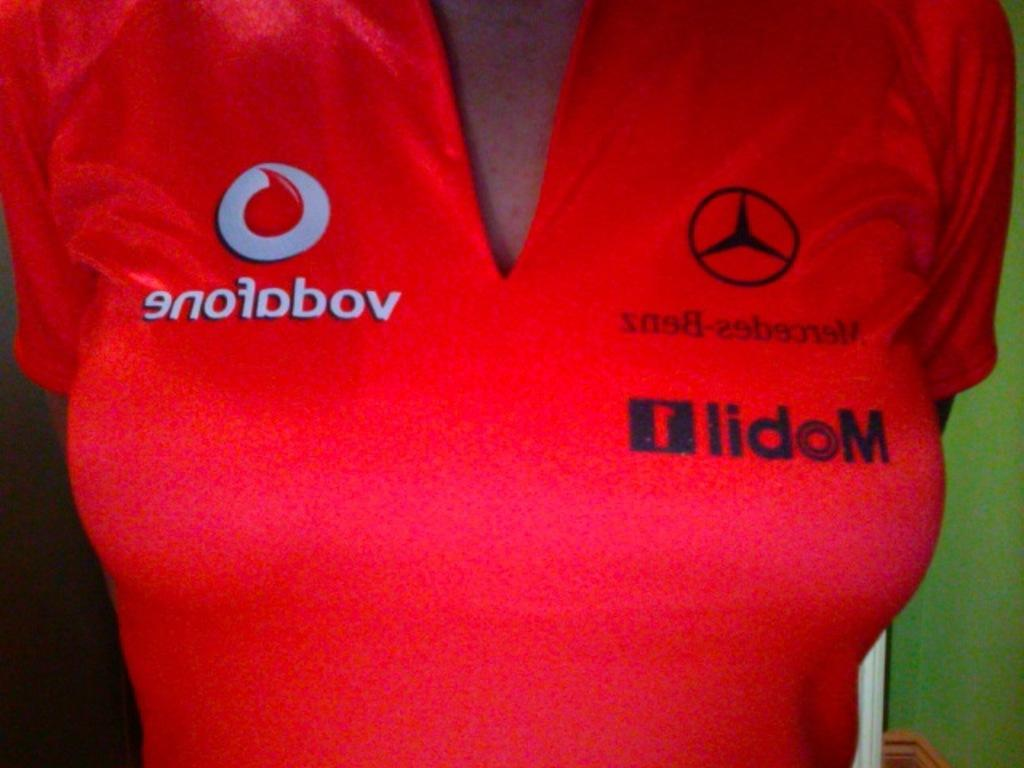Provide a one-sentence caption for the provided image. A red v-neck t-shirt with Mobil and Mercedes-Benz logos on it. 